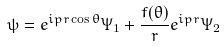Convert formula to latex. <formula><loc_0><loc_0><loc_500><loc_500>\psi = e ^ { i p r \cos \theta } \Psi _ { 1 } + \frac { f ( \theta ) } { r } e ^ { i p r } \Psi _ { 2 }</formula> 